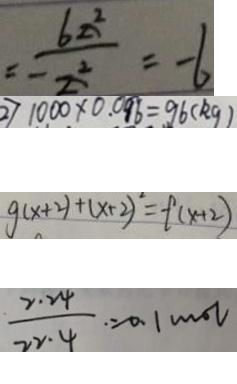Convert formula to latex. <formula><loc_0><loc_0><loc_500><loc_500>= - \frac { 6 z ^ { Z } } { Z ^ { 2 } } = - 6 
 2 ) 1 0 0 0 \times 0 . 0 9 6 = 9 6 ( k g ) 
 g ( x + 2 ) + ( x + 2 ) ^ { 2 } = f ( x + 2 ) 
 \frac { 2 . 2 4 } { 2 2 . 4 } = 0 . 1 m o l</formula> 